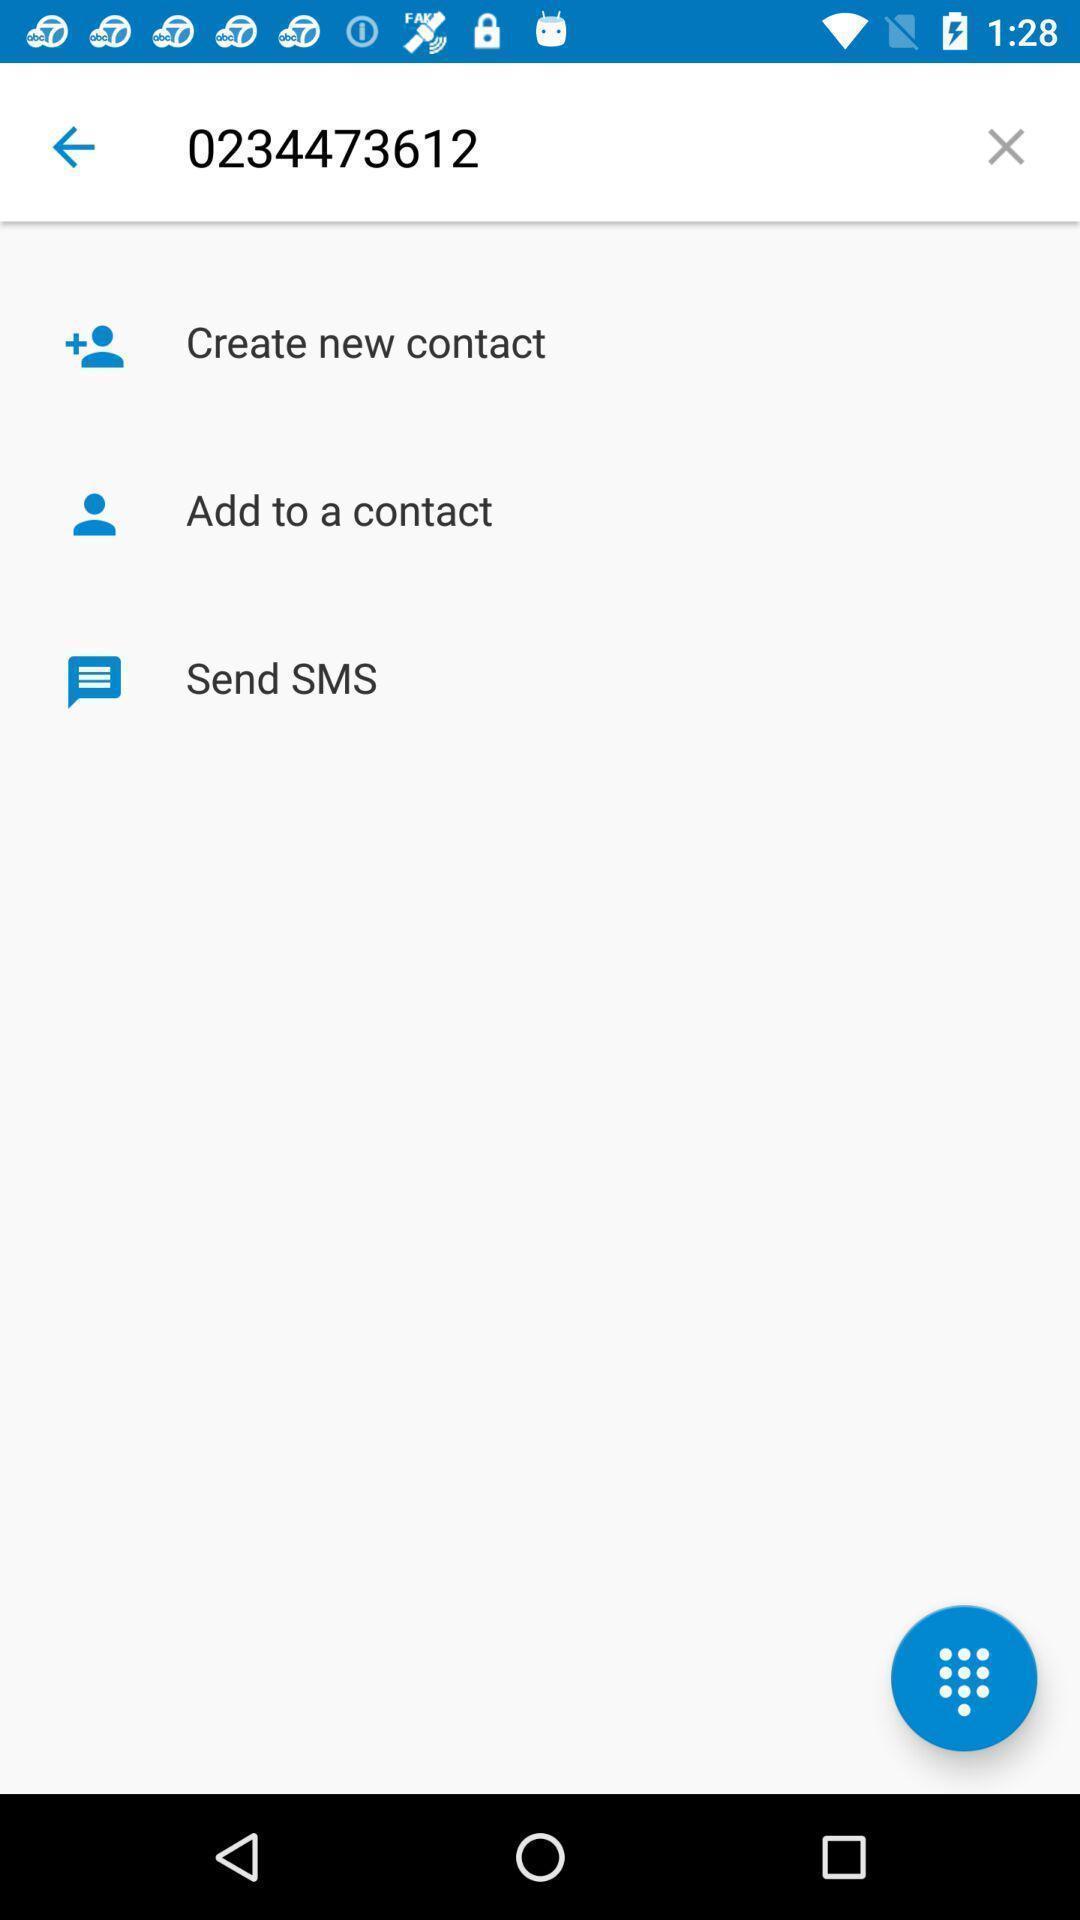What details can you identify in this image? Screen shows of creating a contact. 